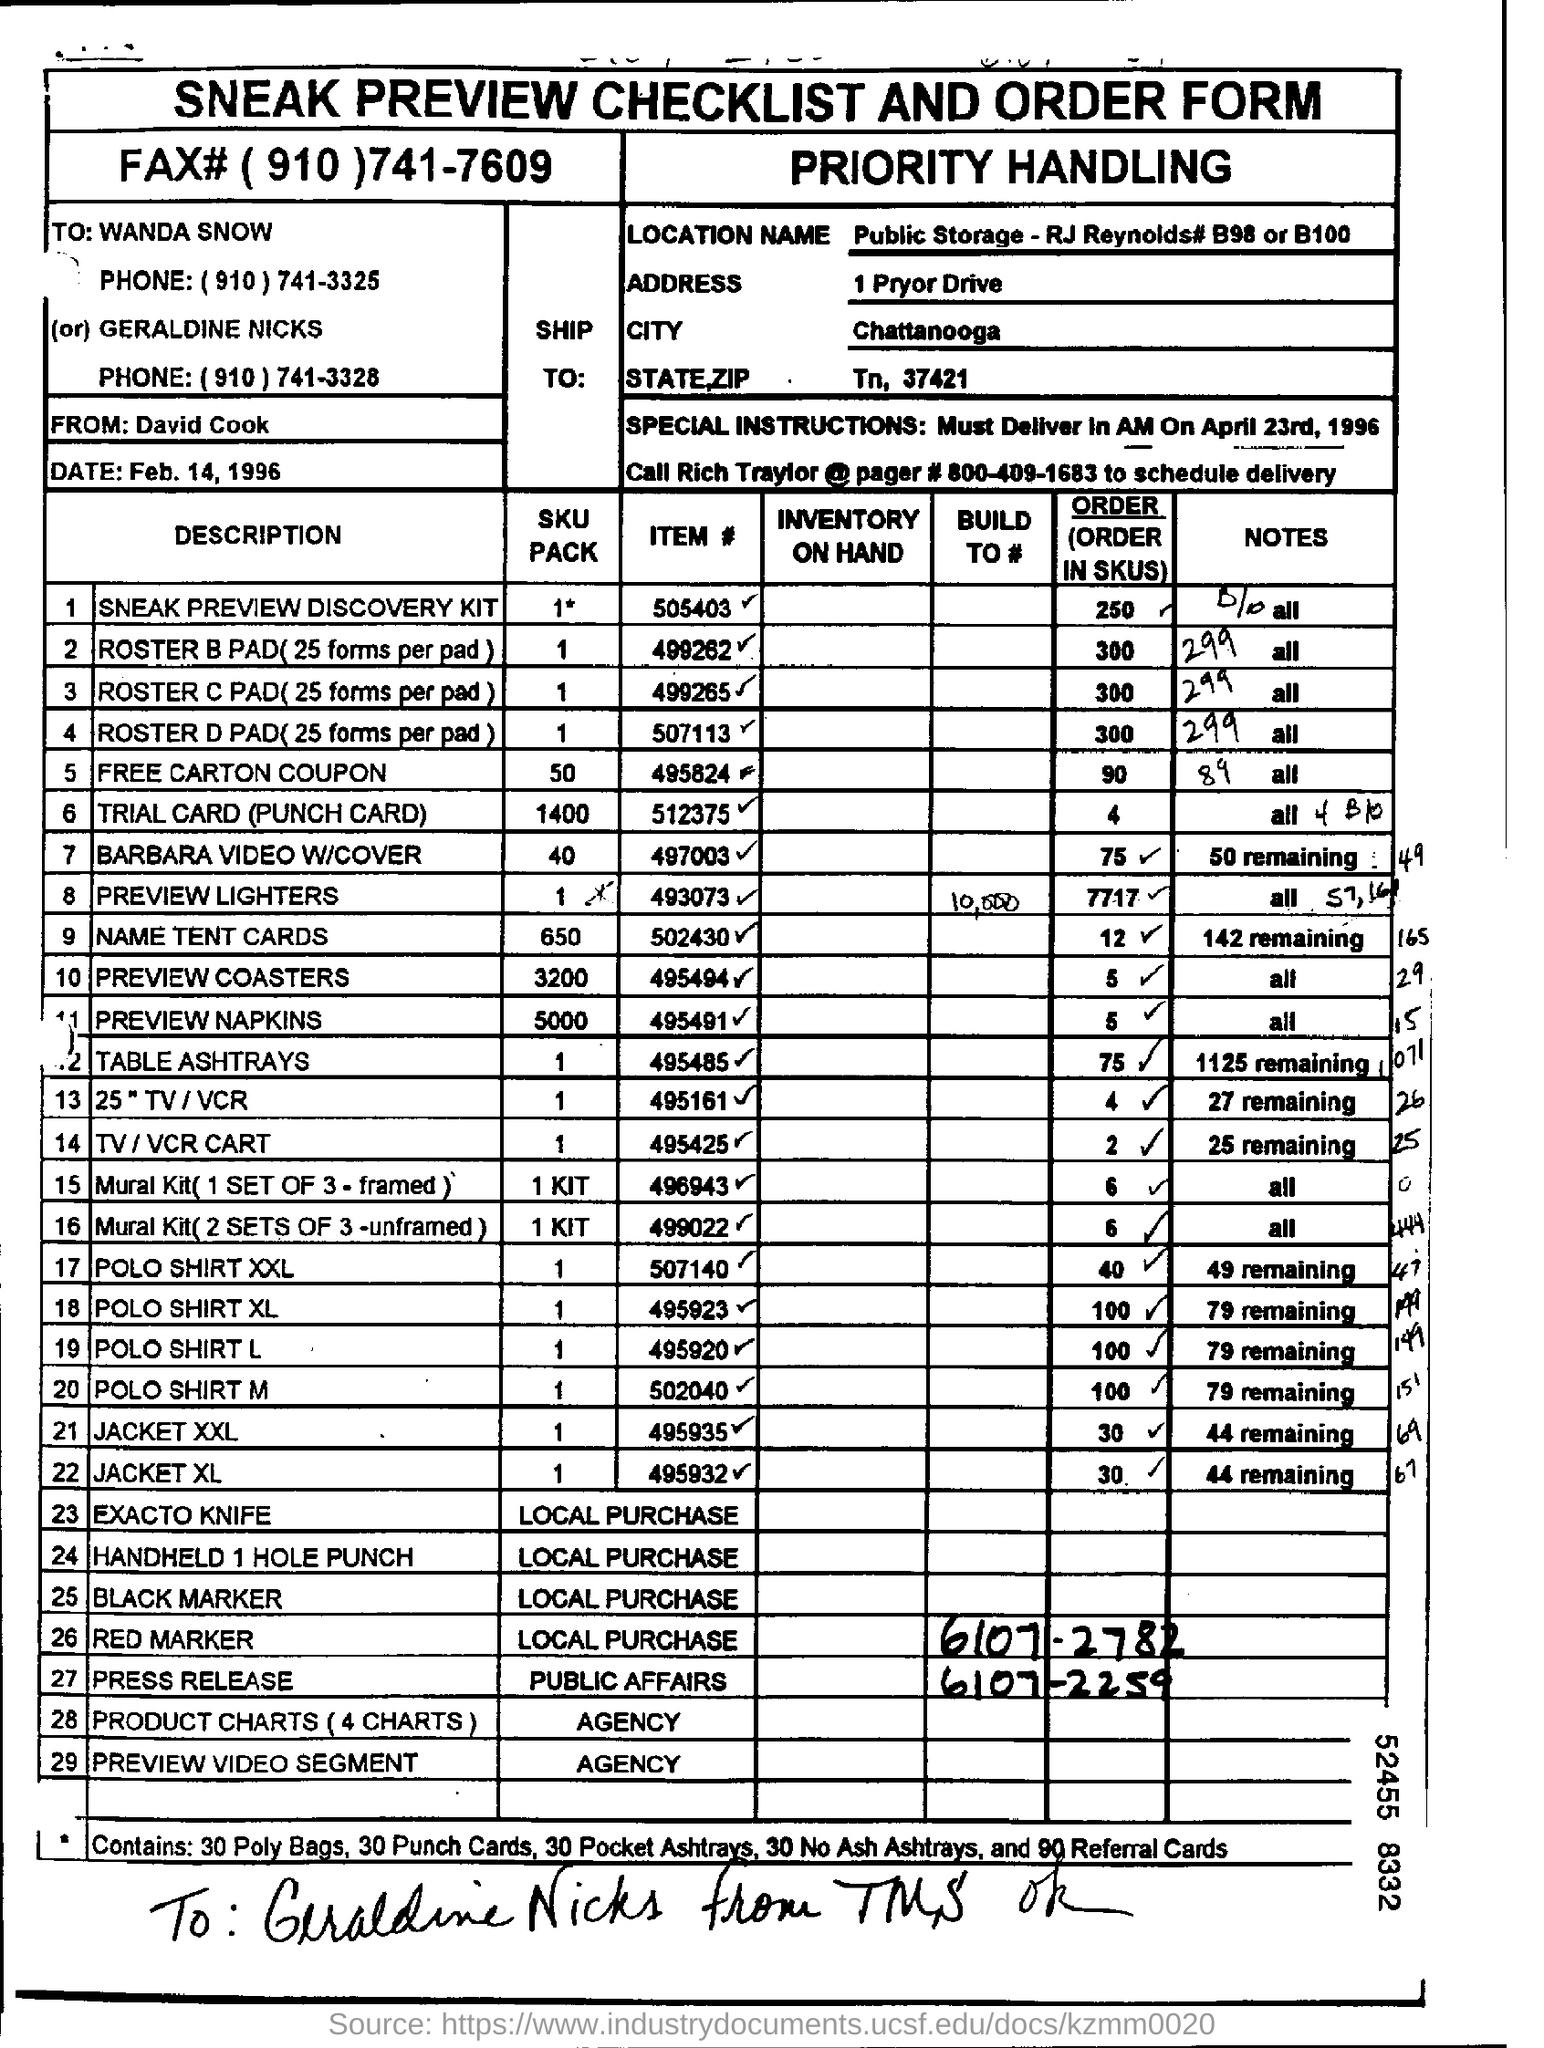List a handful of essential elements in this visual. The heading of the document is 'SNEAK PREVIEW CHECKLIST AND ORDER FORM.' The city of Chattanooga is specifically referred to in the text. 